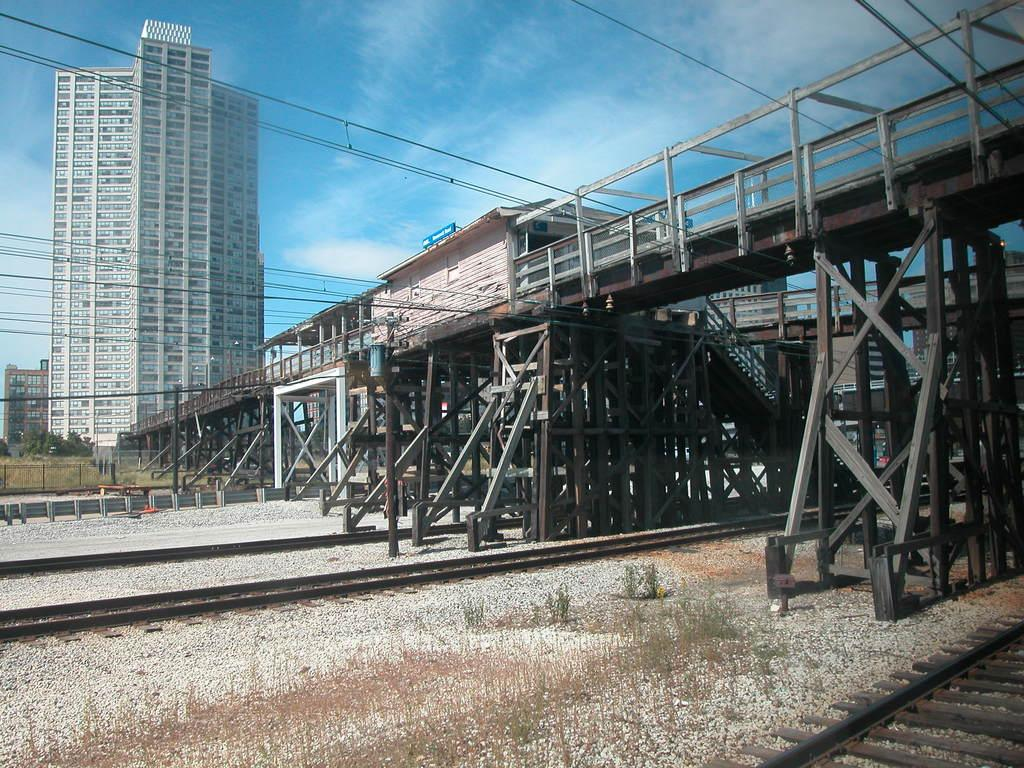What can be seen running through the image? There are tracks in the image. What structure is located on the right side of the image? There is a bridge on the right side of the image. What else is visible in the image besides the tracks and bridge? There are wires visible in the image. What can be seen in the background of the image? There are buildings, plants, and the sky visible in the background of the image. What type of wristwatch is visible on the bridge in the image? There is no wristwatch present in the image; the focus is on the tracks, bridge, wires, buildings, plants, and sky. Can you tell me how many fingers are holding the crib in the image? There is no crib present in the image, and therefore no fingers holding it. 